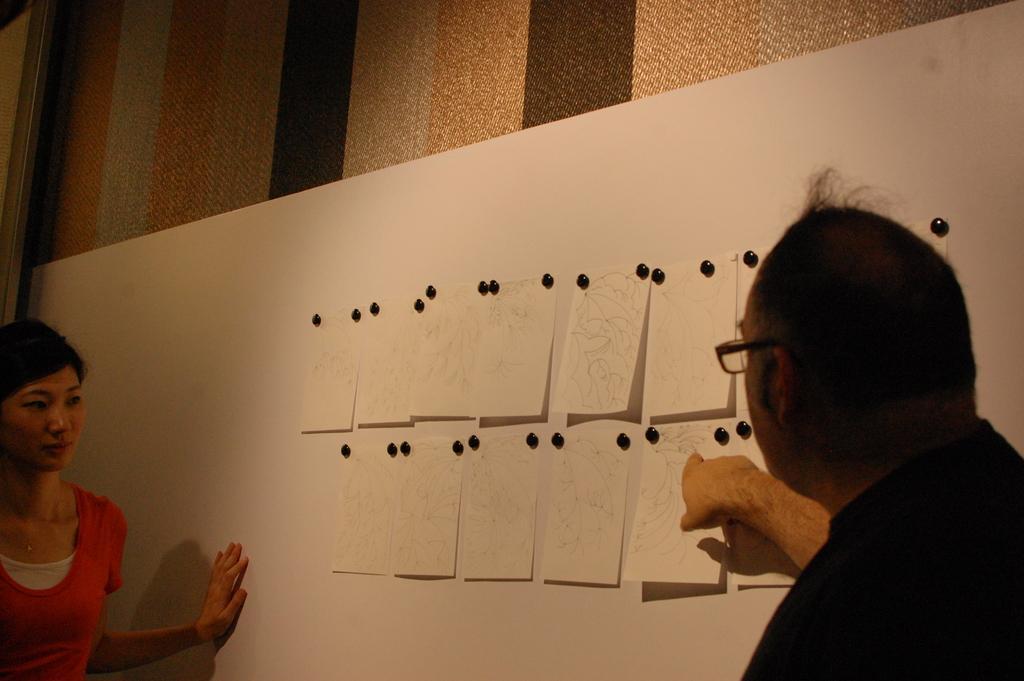Describe this image in one or two sentences. In this image we can see there is a boy and a girl looking to the papers which are attached to the board. In the background there is a wall. 